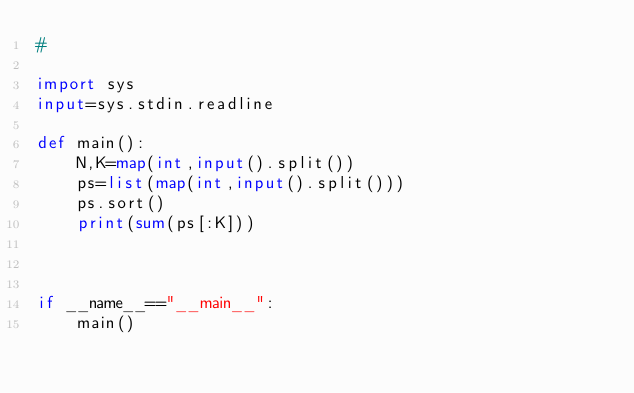<code> <loc_0><loc_0><loc_500><loc_500><_Python_>#

import sys
input=sys.stdin.readline

def main():
    N,K=map(int,input().split())
    ps=list(map(int,input().split()))
    ps.sort()
    print(sum(ps[:K]))
    
    
    
if __name__=="__main__":
    main()
</code> 